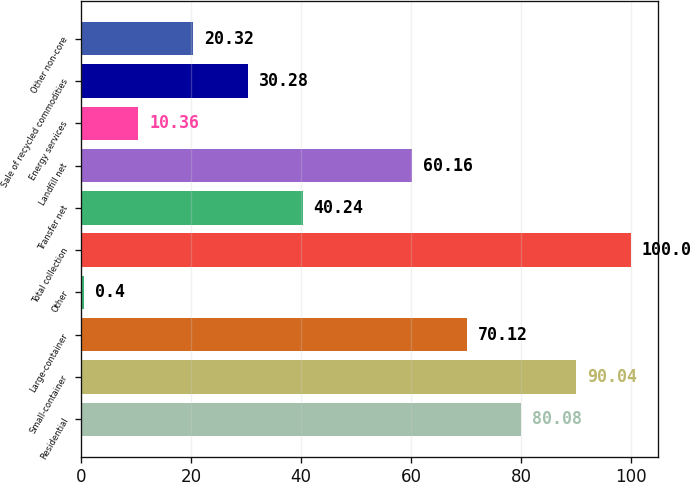Convert chart. <chart><loc_0><loc_0><loc_500><loc_500><bar_chart><fcel>Residential<fcel>Small-container<fcel>Large-container<fcel>Other<fcel>Total collection<fcel>Transfer net<fcel>Landfill net<fcel>Energy services<fcel>Sale of recycled commodities<fcel>Other non-core<nl><fcel>80.08<fcel>90.04<fcel>70.12<fcel>0.4<fcel>100<fcel>40.24<fcel>60.16<fcel>10.36<fcel>30.28<fcel>20.32<nl></chart> 